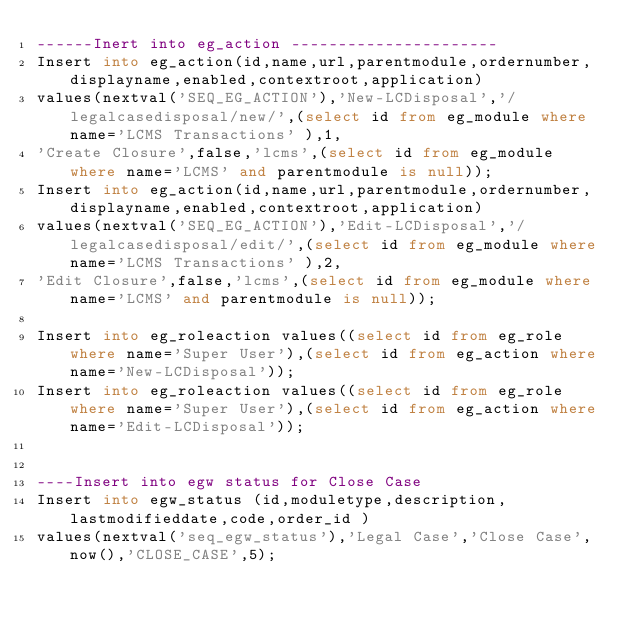<code> <loc_0><loc_0><loc_500><loc_500><_SQL_>------Inert into eg_action ----------------------
Insert into eg_action(id,name,url,parentmodule,ordernumber,displayname,enabled,contextroot,application) 
values(nextval('SEQ_EG_ACTION'),'New-LCDisposal','/legalcasedisposal/new/',(select id from eg_module where name='LCMS Transactions' ),1,
'Create Closure',false,'lcms',(select id from eg_module where name='LCMS' and parentmodule is null));
Insert into eg_action(id,name,url,parentmodule,ordernumber,displayname,enabled,contextroot,application) 
values(nextval('SEQ_EG_ACTION'),'Edit-LCDisposal','/legalcasedisposal/edit/',(select id from eg_module where name='LCMS Transactions' ),2,
'Edit Closure',false,'lcms',(select id from eg_module where name='LCMS' and parentmodule is null));

Insert into eg_roleaction values((select id from eg_role where name='Super User'),(select id from eg_action where name='New-LCDisposal'));
Insert into eg_roleaction values((select id from eg_role where name='Super User'),(select id from eg_action where name='Edit-LCDisposal'));


----Insert into egw status for Close Case
Insert into egw_status (id,moduletype,description,lastmodifieddate,code,order_id )
values(nextval('seq_egw_status'),'Legal Case','Close Case',now(),'CLOSE_CASE',5);

</code> 